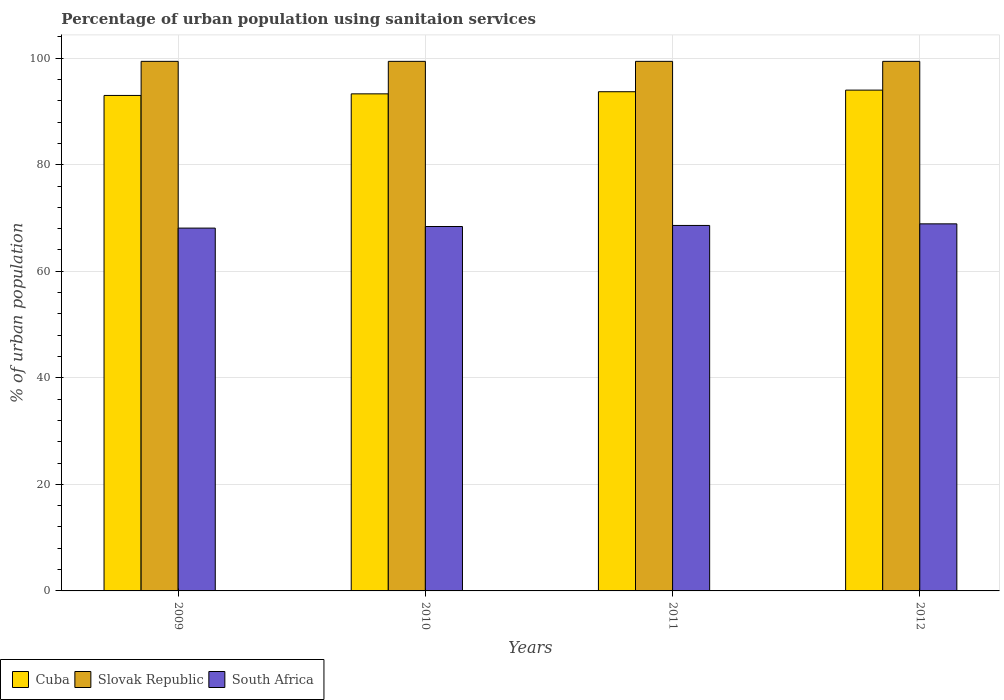How many bars are there on the 3rd tick from the left?
Offer a terse response. 3. How many bars are there on the 4th tick from the right?
Give a very brief answer. 3. In how many cases, is the number of bars for a given year not equal to the number of legend labels?
Your response must be concise. 0. What is the percentage of urban population using sanitaion services in South Africa in 2011?
Your answer should be very brief. 68.6. Across all years, what is the maximum percentage of urban population using sanitaion services in Cuba?
Ensure brevity in your answer.  94. Across all years, what is the minimum percentage of urban population using sanitaion services in South Africa?
Provide a short and direct response. 68.1. What is the total percentage of urban population using sanitaion services in Slovak Republic in the graph?
Offer a very short reply. 397.6. What is the difference between the percentage of urban population using sanitaion services in South Africa in 2009 and that in 2010?
Keep it short and to the point. -0.3. What is the difference between the percentage of urban population using sanitaion services in South Africa in 2011 and the percentage of urban population using sanitaion services in Cuba in 2012?
Ensure brevity in your answer.  -25.4. What is the average percentage of urban population using sanitaion services in Slovak Republic per year?
Your answer should be compact. 99.4. In the year 2012, what is the difference between the percentage of urban population using sanitaion services in Slovak Republic and percentage of urban population using sanitaion services in Cuba?
Make the answer very short. 5.4. What is the ratio of the percentage of urban population using sanitaion services in Cuba in 2011 to that in 2012?
Your answer should be very brief. 1. Is the difference between the percentage of urban population using sanitaion services in Slovak Republic in 2009 and 2011 greater than the difference between the percentage of urban population using sanitaion services in Cuba in 2009 and 2011?
Your answer should be compact. Yes. What is the difference between the highest and the second highest percentage of urban population using sanitaion services in Cuba?
Provide a succinct answer. 0.3. What is the difference between the highest and the lowest percentage of urban population using sanitaion services in South Africa?
Your response must be concise. 0.8. In how many years, is the percentage of urban population using sanitaion services in Cuba greater than the average percentage of urban population using sanitaion services in Cuba taken over all years?
Make the answer very short. 2. What does the 2nd bar from the left in 2009 represents?
Keep it short and to the point. Slovak Republic. What does the 1st bar from the right in 2012 represents?
Give a very brief answer. South Africa. How many bars are there?
Make the answer very short. 12. Are all the bars in the graph horizontal?
Provide a succinct answer. No. How many years are there in the graph?
Offer a very short reply. 4. What is the difference between two consecutive major ticks on the Y-axis?
Your response must be concise. 20. Does the graph contain any zero values?
Provide a short and direct response. No. Where does the legend appear in the graph?
Provide a succinct answer. Bottom left. How many legend labels are there?
Give a very brief answer. 3. What is the title of the graph?
Ensure brevity in your answer.  Percentage of urban population using sanitaion services. Does "Luxembourg" appear as one of the legend labels in the graph?
Offer a very short reply. No. What is the label or title of the X-axis?
Offer a very short reply. Years. What is the label or title of the Y-axis?
Provide a succinct answer. % of urban population. What is the % of urban population in Cuba in 2009?
Your answer should be very brief. 93. What is the % of urban population of Slovak Republic in 2009?
Offer a terse response. 99.4. What is the % of urban population in South Africa in 2009?
Give a very brief answer. 68.1. What is the % of urban population of Cuba in 2010?
Keep it short and to the point. 93.3. What is the % of urban population in Slovak Republic in 2010?
Your answer should be compact. 99.4. What is the % of urban population in South Africa in 2010?
Your answer should be very brief. 68.4. What is the % of urban population of Cuba in 2011?
Your answer should be compact. 93.7. What is the % of urban population of Slovak Republic in 2011?
Give a very brief answer. 99.4. What is the % of urban population of South Africa in 2011?
Offer a very short reply. 68.6. What is the % of urban population of Cuba in 2012?
Ensure brevity in your answer.  94. What is the % of urban population in Slovak Republic in 2012?
Your answer should be very brief. 99.4. What is the % of urban population in South Africa in 2012?
Your response must be concise. 68.9. Across all years, what is the maximum % of urban population in Cuba?
Give a very brief answer. 94. Across all years, what is the maximum % of urban population of Slovak Republic?
Your answer should be compact. 99.4. Across all years, what is the maximum % of urban population in South Africa?
Provide a short and direct response. 68.9. Across all years, what is the minimum % of urban population of Cuba?
Provide a succinct answer. 93. Across all years, what is the minimum % of urban population in Slovak Republic?
Provide a short and direct response. 99.4. Across all years, what is the minimum % of urban population of South Africa?
Offer a very short reply. 68.1. What is the total % of urban population of Cuba in the graph?
Offer a terse response. 374. What is the total % of urban population in Slovak Republic in the graph?
Offer a very short reply. 397.6. What is the total % of urban population of South Africa in the graph?
Offer a terse response. 274. What is the difference between the % of urban population of Cuba in 2009 and that in 2010?
Offer a terse response. -0.3. What is the difference between the % of urban population of Slovak Republic in 2009 and that in 2010?
Keep it short and to the point. 0. What is the difference between the % of urban population in South Africa in 2009 and that in 2010?
Give a very brief answer. -0.3. What is the difference between the % of urban population in Slovak Republic in 2009 and that in 2011?
Ensure brevity in your answer.  0. What is the difference between the % of urban population of South Africa in 2009 and that in 2011?
Offer a terse response. -0.5. What is the difference between the % of urban population in South Africa in 2009 and that in 2012?
Offer a very short reply. -0.8. What is the difference between the % of urban population in Cuba in 2010 and that in 2011?
Your answer should be very brief. -0.4. What is the difference between the % of urban population of Slovak Republic in 2010 and that in 2011?
Your answer should be very brief. 0. What is the difference between the % of urban population in Slovak Republic in 2011 and that in 2012?
Offer a terse response. 0. What is the difference between the % of urban population of Cuba in 2009 and the % of urban population of South Africa in 2010?
Offer a terse response. 24.6. What is the difference between the % of urban population in Slovak Republic in 2009 and the % of urban population in South Africa in 2010?
Give a very brief answer. 31. What is the difference between the % of urban population of Cuba in 2009 and the % of urban population of South Africa in 2011?
Your answer should be very brief. 24.4. What is the difference between the % of urban population in Slovak Republic in 2009 and the % of urban population in South Africa in 2011?
Your answer should be very brief. 30.8. What is the difference between the % of urban population of Cuba in 2009 and the % of urban population of South Africa in 2012?
Offer a terse response. 24.1. What is the difference between the % of urban population in Slovak Republic in 2009 and the % of urban population in South Africa in 2012?
Ensure brevity in your answer.  30.5. What is the difference between the % of urban population in Cuba in 2010 and the % of urban population in Slovak Republic in 2011?
Keep it short and to the point. -6.1. What is the difference between the % of urban population of Cuba in 2010 and the % of urban population of South Africa in 2011?
Offer a very short reply. 24.7. What is the difference between the % of urban population of Slovak Republic in 2010 and the % of urban population of South Africa in 2011?
Your response must be concise. 30.8. What is the difference between the % of urban population of Cuba in 2010 and the % of urban population of Slovak Republic in 2012?
Ensure brevity in your answer.  -6.1. What is the difference between the % of urban population of Cuba in 2010 and the % of urban population of South Africa in 2012?
Provide a succinct answer. 24.4. What is the difference between the % of urban population in Slovak Republic in 2010 and the % of urban population in South Africa in 2012?
Keep it short and to the point. 30.5. What is the difference between the % of urban population in Cuba in 2011 and the % of urban population in South Africa in 2012?
Provide a short and direct response. 24.8. What is the difference between the % of urban population in Slovak Republic in 2011 and the % of urban population in South Africa in 2012?
Provide a short and direct response. 30.5. What is the average % of urban population in Cuba per year?
Offer a very short reply. 93.5. What is the average % of urban population of Slovak Republic per year?
Make the answer very short. 99.4. What is the average % of urban population in South Africa per year?
Keep it short and to the point. 68.5. In the year 2009, what is the difference between the % of urban population of Cuba and % of urban population of Slovak Republic?
Your answer should be very brief. -6.4. In the year 2009, what is the difference between the % of urban population in Cuba and % of urban population in South Africa?
Your answer should be compact. 24.9. In the year 2009, what is the difference between the % of urban population of Slovak Republic and % of urban population of South Africa?
Make the answer very short. 31.3. In the year 2010, what is the difference between the % of urban population in Cuba and % of urban population in Slovak Republic?
Provide a short and direct response. -6.1. In the year 2010, what is the difference between the % of urban population in Cuba and % of urban population in South Africa?
Make the answer very short. 24.9. In the year 2011, what is the difference between the % of urban population in Cuba and % of urban population in Slovak Republic?
Provide a succinct answer. -5.7. In the year 2011, what is the difference between the % of urban population in Cuba and % of urban population in South Africa?
Offer a very short reply. 25.1. In the year 2011, what is the difference between the % of urban population in Slovak Republic and % of urban population in South Africa?
Give a very brief answer. 30.8. In the year 2012, what is the difference between the % of urban population of Cuba and % of urban population of South Africa?
Your answer should be compact. 25.1. In the year 2012, what is the difference between the % of urban population of Slovak Republic and % of urban population of South Africa?
Offer a very short reply. 30.5. What is the ratio of the % of urban population in Slovak Republic in 2009 to that in 2010?
Offer a terse response. 1. What is the ratio of the % of urban population of Cuba in 2009 to that in 2011?
Ensure brevity in your answer.  0.99. What is the ratio of the % of urban population in Cuba in 2009 to that in 2012?
Make the answer very short. 0.99. What is the ratio of the % of urban population of Slovak Republic in 2009 to that in 2012?
Ensure brevity in your answer.  1. What is the ratio of the % of urban population in South Africa in 2009 to that in 2012?
Your answer should be very brief. 0.99. What is the ratio of the % of urban population of Cuba in 2010 to that in 2011?
Offer a very short reply. 1. What is the ratio of the % of urban population in Slovak Republic in 2010 to that in 2011?
Make the answer very short. 1. What is the ratio of the % of urban population of Cuba in 2010 to that in 2012?
Ensure brevity in your answer.  0.99. What is the ratio of the % of urban population of Slovak Republic in 2010 to that in 2012?
Your response must be concise. 1. What is the ratio of the % of urban population in South Africa in 2010 to that in 2012?
Your answer should be compact. 0.99. What is the ratio of the % of urban population in Cuba in 2011 to that in 2012?
Keep it short and to the point. 1. What is the difference between the highest and the lowest % of urban population in Cuba?
Keep it short and to the point. 1. What is the difference between the highest and the lowest % of urban population of Slovak Republic?
Keep it short and to the point. 0. What is the difference between the highest and the lowest % of urban population in South Africa?
Your response must be concise. 0.8. 